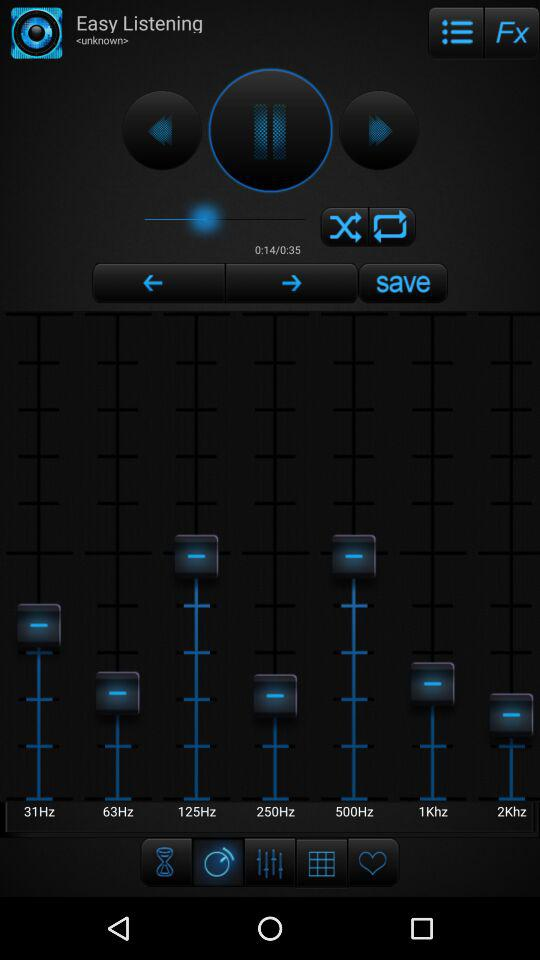What is the title of the playing audio? The title of the audio is "Easy Listening". 